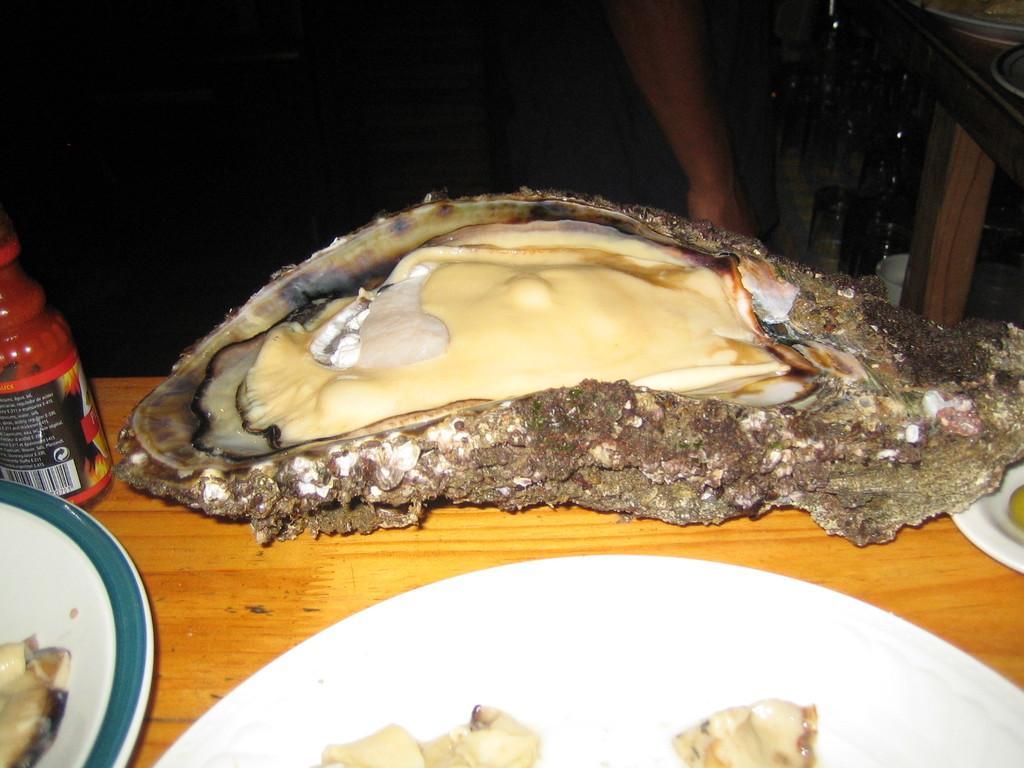How would you summarize this image in a sentence or two? In this image I can see few plates, a red colour thing and I can see food in plates. In background can see a hand of a person and I can see this image is in dark from background. 